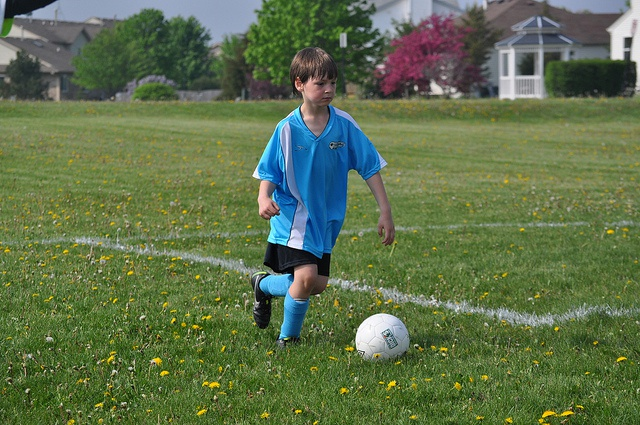Describe the objects in this image and their specific colors. I can see people in darkgray, blue, black, and gray tones and sports ball in darkgray, lightgray, and gray tones in this image. 